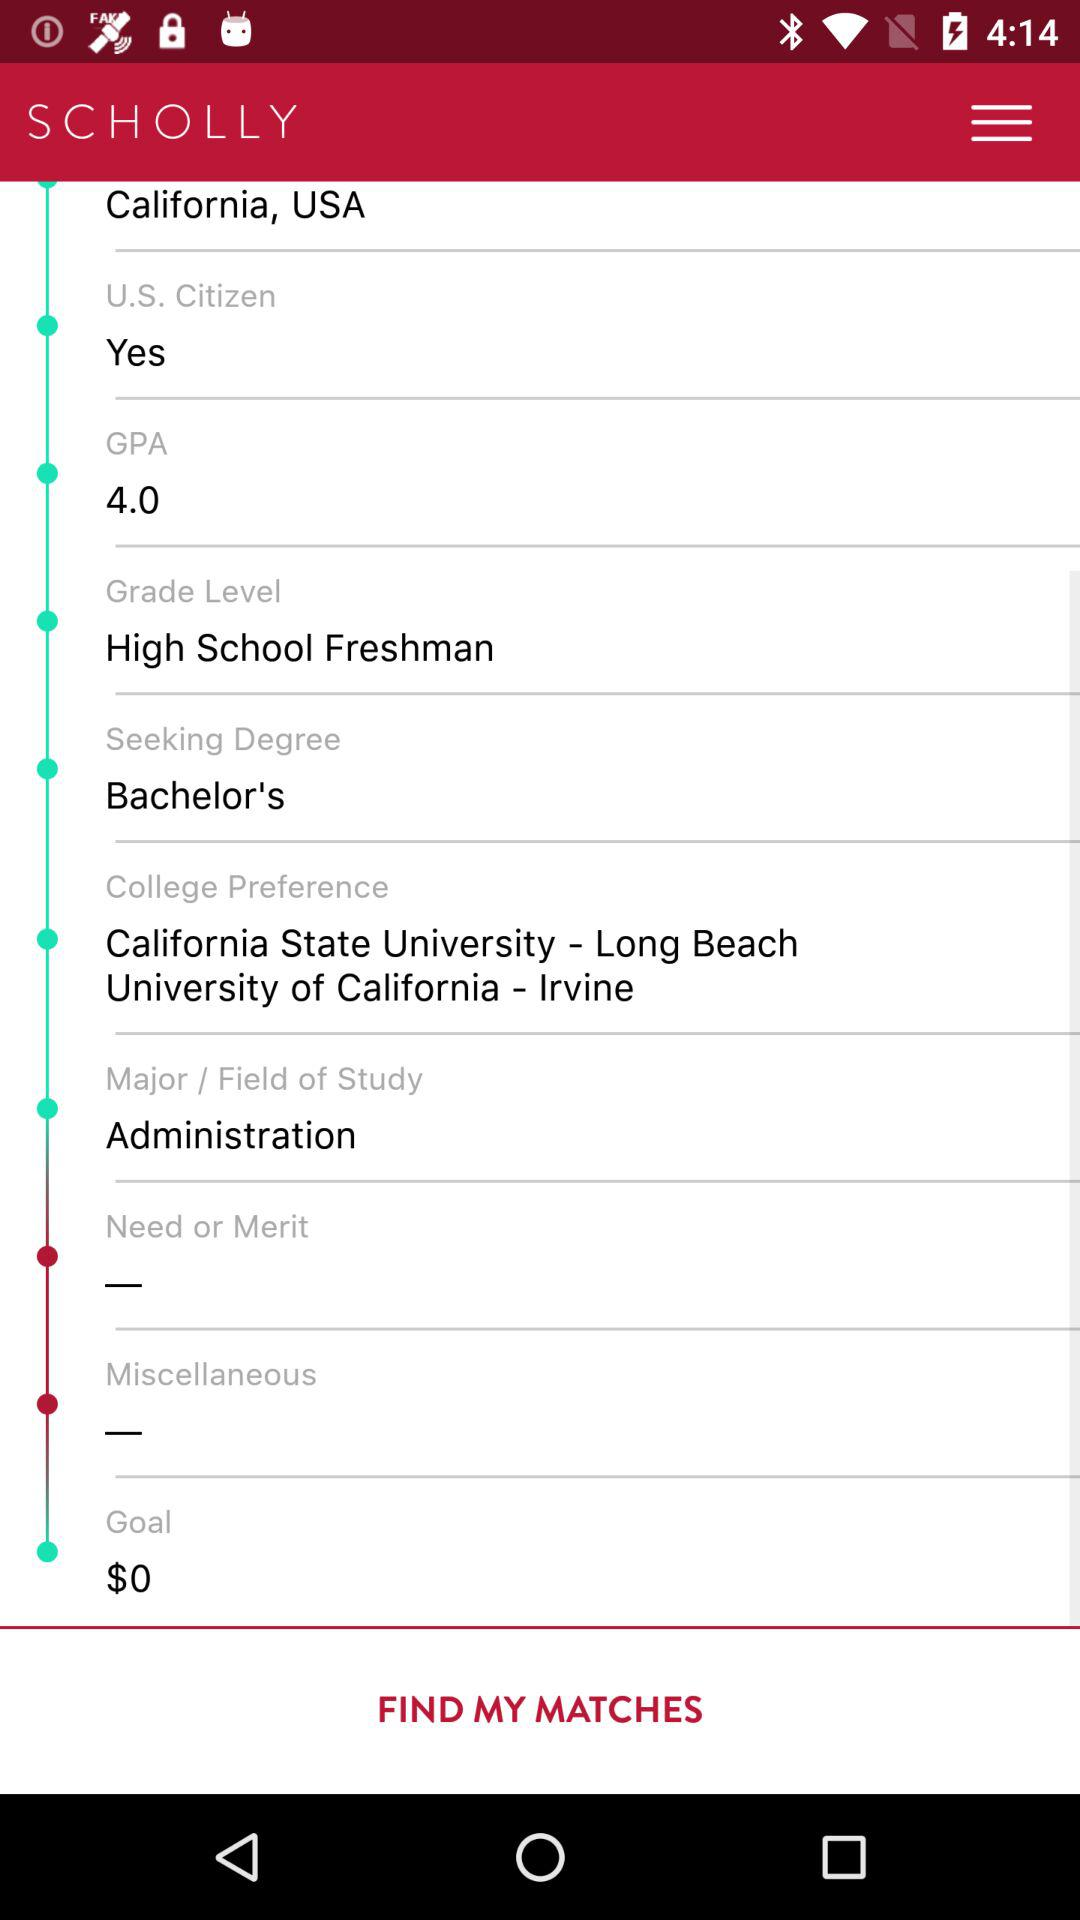How much is the GPA? The GPA is 4.0. 